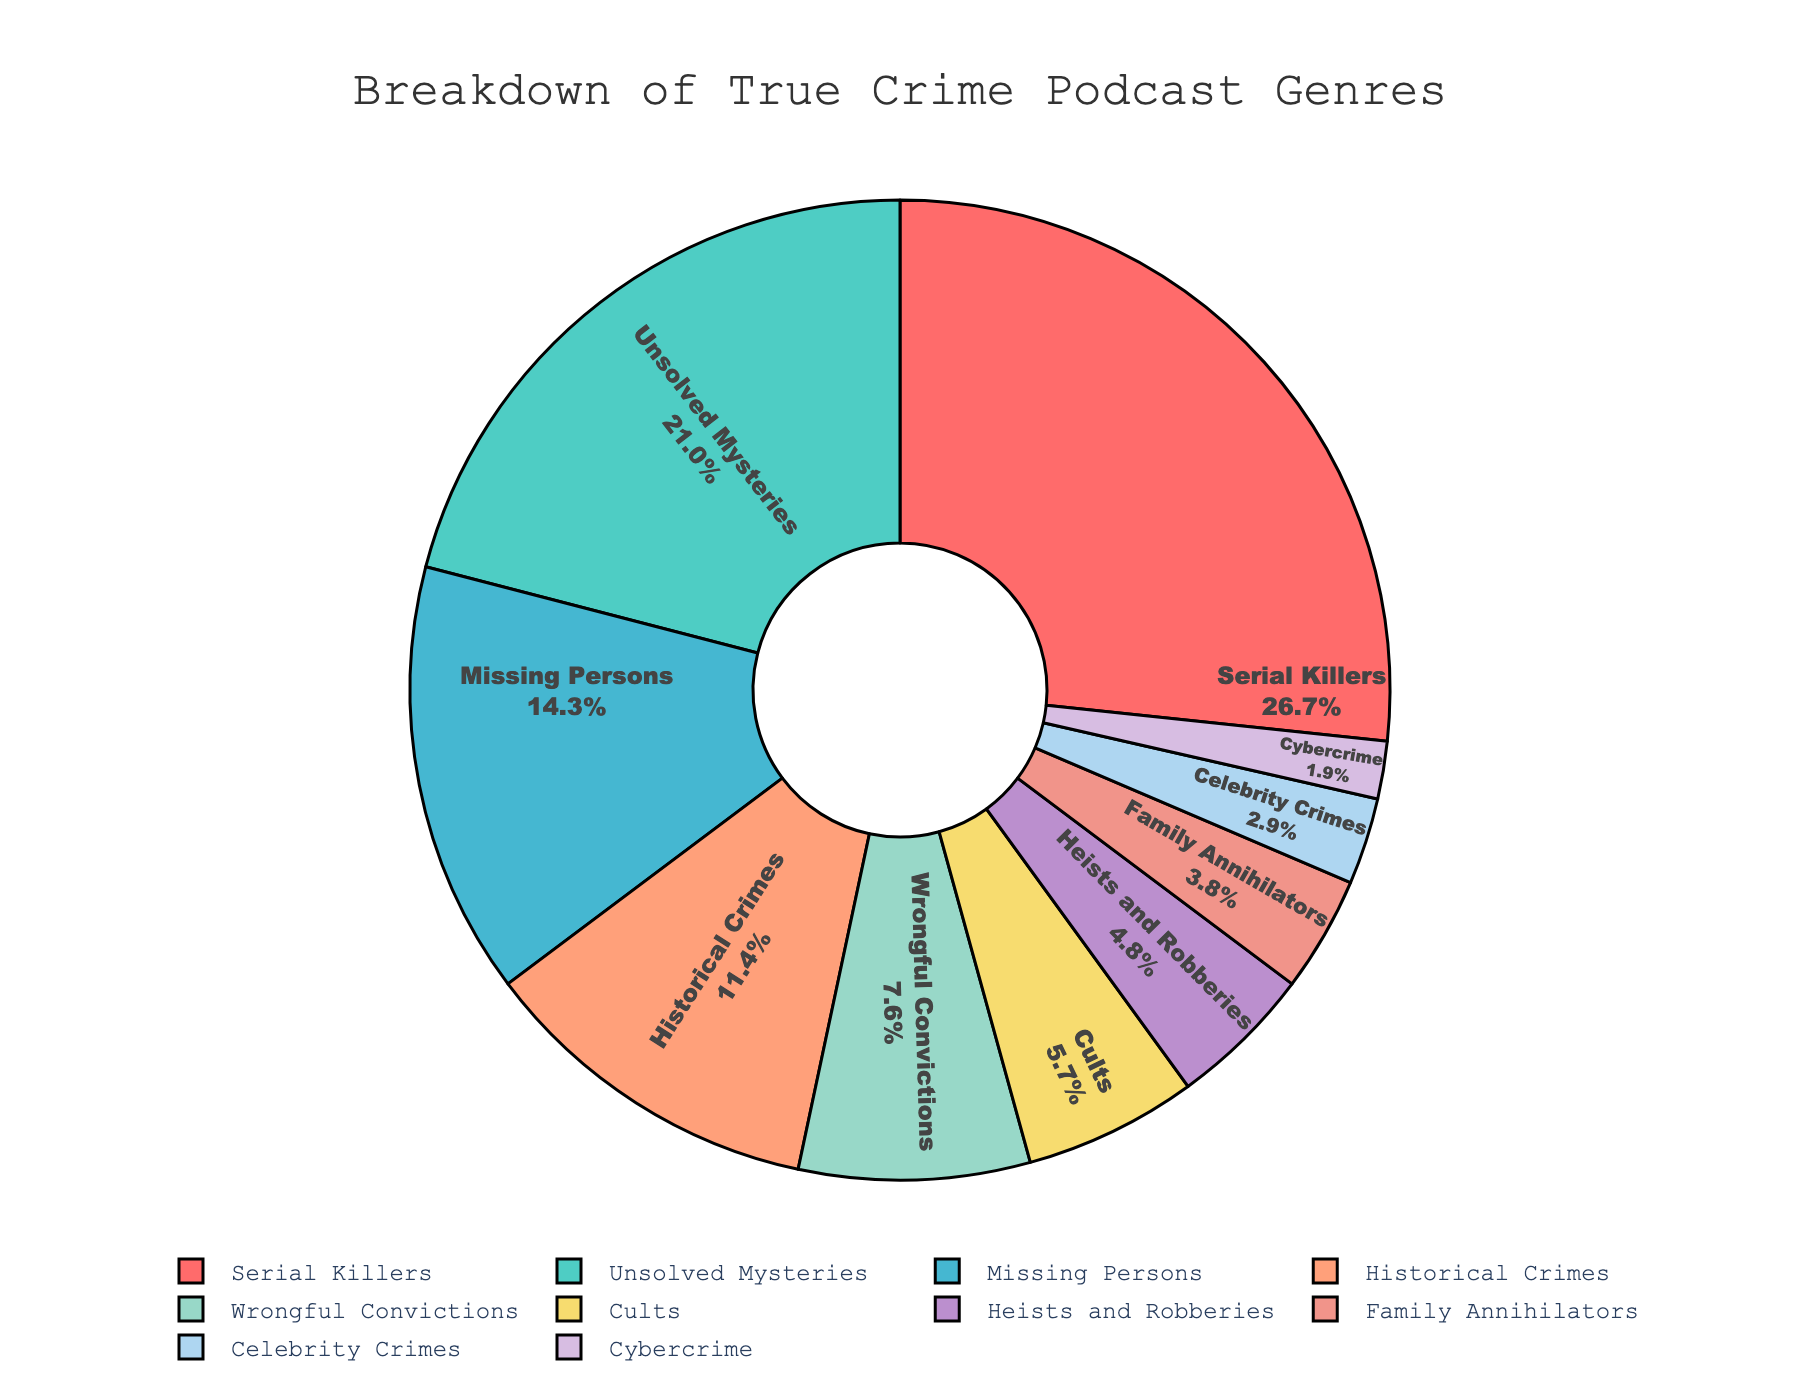Which genre is the most popular? The segment with the label "Serial Killers" has the highest percentage value of 28%, making it the most popular genre.
Answer: Serial Killers Which genres have a percentage lower than 10%? The segments labeled "Wrongful Convictions," "Cults," "Heists and Robberies," "Family Annihilators," "Celebrity Crimes," and "Cybercrime" all have values less than 10%.
Answer: Wrongful Convictions, Cults, Heists and Robberies, Family Annihilators, Celebrity Crimes, Cybercrime Which genre occupies the smallest portion of the pie chart? The segment labeled "Cybercrime" has the smallest percentage value of 2%, making it the smallest portion.
Answer: Cybercrime What is the combined percentage of 'Serial Killers' and 'Unsolved Mysteries'? The percentage for "Serial Killers" is 28%, and for "Unsolved Mysteries," it is 22%. Adding them together: 28% + 22% = 50%.
Answer: 50% How many genres have a percentage above 20%? Only the segments labeled "Serial Killers" (28%) and "Unsolved Mysteries" (22%) have percentages above 20%. Thus, there are 2 genres above 20%.
Answer: 2 Is the percentage of 'Historical Crimes' greater than 'Missing Persons'? The percentage for "Historical Crimes" is 12%, whereas "Missing Persons" is 15%. Thus, "Historical Crimes" is not greater than "Missing Persons."
Answer: No What is the difference in percentage between 'Cults' and 'Family Annihilators'? The percentage for "Cults" is 6%, and for "Family Annihilators," it is 4%. The difference is 6% - 4% = 2%.
Answer: 2% Which genre is directly opposite to 'Historical Crimes' in the pie chart? The segment labeled "Cults" is directly opposite "Historical Crimes," both visually separated by the neighboring segments, forming a 180-degree angle.
Answer: Cults What colors represent 'Unsolved Mysteries' and 'Celebrity Crimes'? The segment labeled "Unsolved Mysteries" is represented by the color green (4ECDC4 as per the code), and "Celebrity Crimes" is represented by blue (AED6F1 as per the code).
Answer: Green and Blue What is the total percentage for genres related to crime investigations ('Serial Killers', 'Unsolved Mysteries', and 'Missing Persons')? The percentages for "Serial Killers", "Unsolved Mysteries", and "Missing Persons" are 28%, 22%, and 15% respectively. The total percentage is 28% + 22% + 15% = 65%.
Answer: 65% 